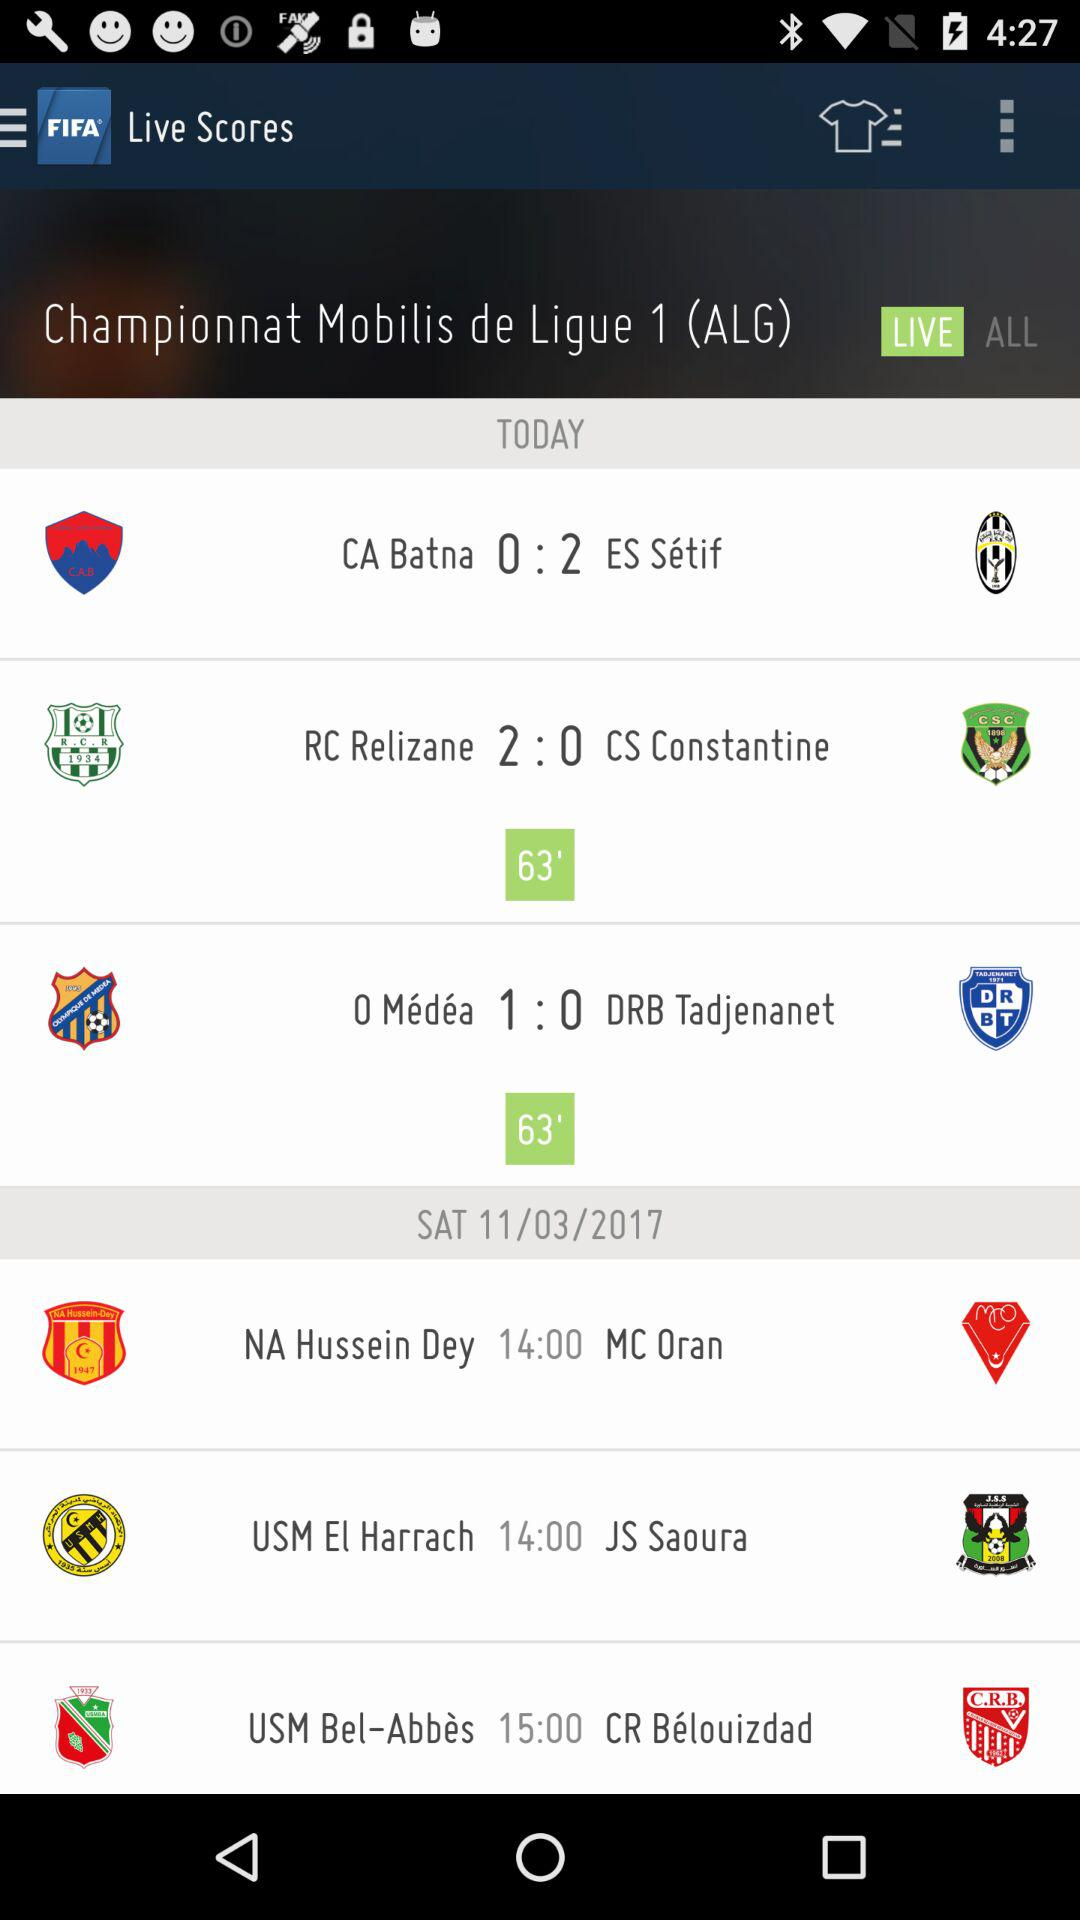Which matches are on Saturday? The matches on Saturday are: NA Hussein Dey vs MC Oran, USM El Harrach vs JS Saoura, and USM Bel-Abbès vs CR Bèlouizdad. 